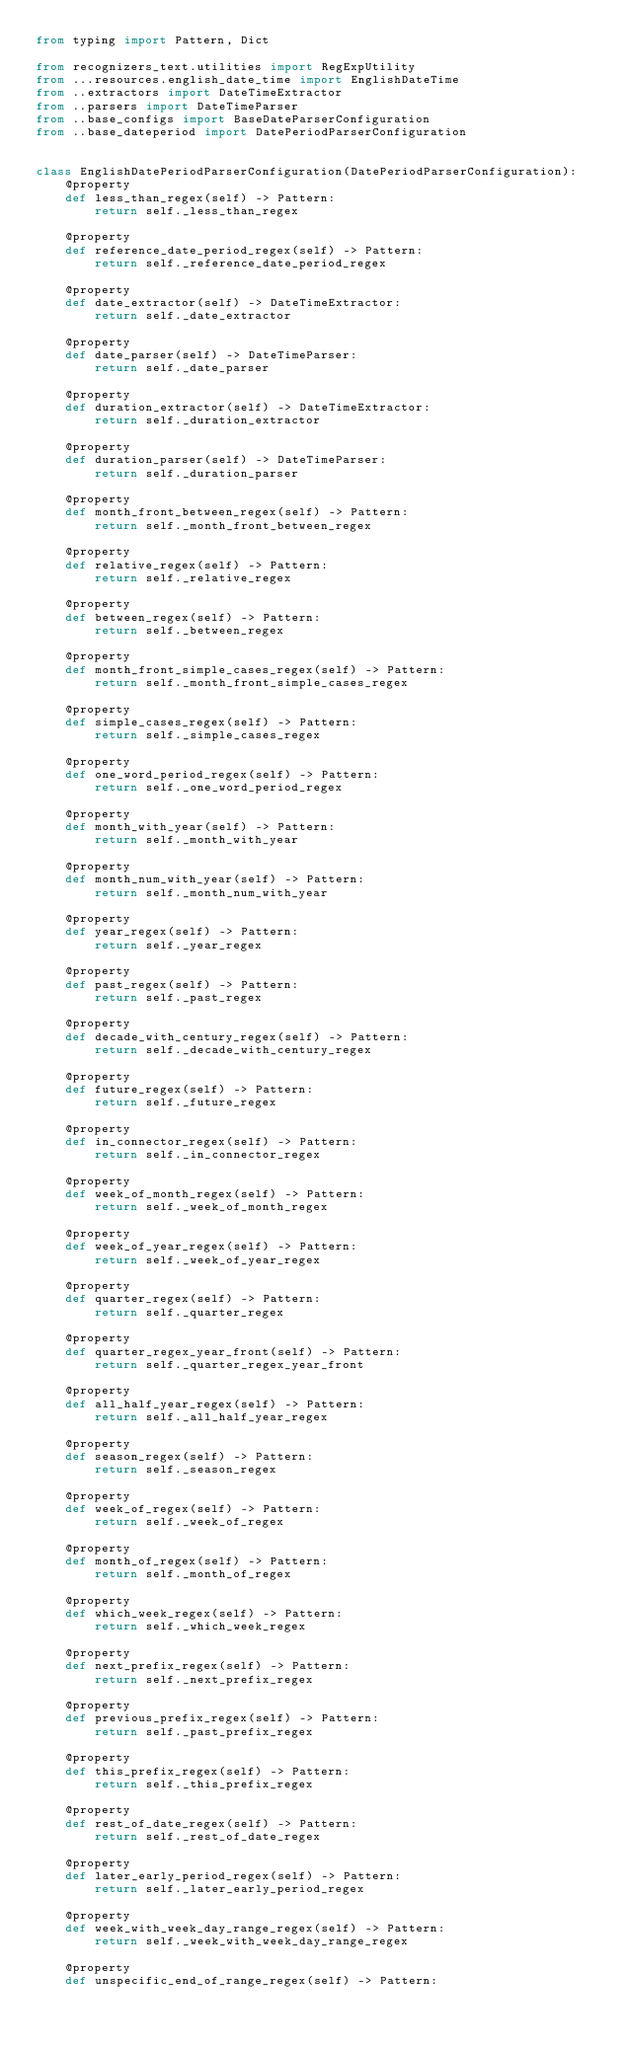<code> <loc_0><loc_0><loc_500><loc_500><_Python_>from typing import Pattern, Dict

from recognizers_text.utilities import RegExpUtility
from ...resources.english_date_time import EnglishDateTime
from ..extractors import DateTimeExtractor
from ..parsers import DateTimeParser
from ..base_configs import BaseDateParserConfiguration
from ..base_dateperiod import DatePeriodParserConfiguration


class EnglishDatePeriodParserConfiguration(DatePeriodParserConfiguration):
    @property
    def less_than_regex(self) -> Pattern:
        return self._less_than_regex

    @property
    def reference_date_period_regex(self) -> Pattern:
        return self._reference_date_period_regex

    @property
    def date_extractor(self) -> DateTimeExtractor:
        return self._date_extractor

    @property
    def date_parser(self) -> DateTimeParser:
        return self._date_parser

    @property
    def duration_extractor(self) -> DateTimeExtractor:
        return self._duration_extractor

    @property
    def duration_parser(self) -> DateTimeParser:
        return self._duration_parser

    @property
    def month_front_between_regex(self) -> Pattern:
        return self._month_front_between_regex

    @property
    def relative_regex(self) -> Pattern:
        return self._relative_regex

    @property
    def between_regex(self) -> Pattern:
        return self._between_regex

    @property
    def month_front_simple_cases_regex(self) -> Pattern:
        return self._month_front_simple_cases_regex

    @property
    def simple_cases_regex(self) -> Pattern:
        return self._simple_cases_regex

    @property
    def one_word_period_regex(self) -> Pattern:
        return self._one_word_period_regex

    @property
    def month_with_year(self) -> Pattern:
        return self._month_with_year

    @property
    def month_num_with_year(self) -> Pattern:
        return self._month_num_with_year

    @property
    def year_regex(self) -> Pattern:
        return self._year_regex

    @property
    def past_regex(self) -> Pattern:
        return self._past_regex

    @property
    def decade_with_century_regex(self) -> Pattern:
        return self._decade_with_century_regex

    @property
    def future_regex(self) -> Pattern:
        return self._future_regex

    @property
    def in_connector_regex(self) -> Pattern:
        return self._in_connector_regex

    @property
    def week_of_month_regex(self) -> Pattern:
        return self._week_of_month_regex

    @property
    def week_of_year_regex(self) -> Pattern:
        return self._week_of_year_regex

    @property
    def quarter_regex(self) -> Pattern:
        return self._quarter_regex

    @property
    def quarter_regex_year_front(self) -> Pattern:
        return self._quarter_regex_year_front

    @property
    def all_half_year_regex(self) -> Pattern:
        return self._all_half_year_regex

    @property
    def season_regex(self) -> Pattern:
        return self._season_regex

    @property
    def week_of_regex(self) -> Pattern:
        return self._week_of_regex

    @property
    def month_of_regex(self) -> Pattern:
        return self._month_of_regex

    @property
    def which_week_regex(self) -> Pattern:
        return self._which_week_regex

    @property
    def next_prefix_regex(self) -> Pattern:
        return self._next_prefix_regex

    @property
    def previous_prefix_regex(self) -> Pattern:
        return self._past_prefix_regex

    @property
    def this_prefix_regex(self) -> Pattern:
        return self._this_prefix_regex

    @property
    def rest_of_date_regex(self) -> Pattern:
        return self._rest_of_date_regex

    @property
    def later_early_period_regex(self) -> Pattern:
        return self._later_early_period_regex

    @property
    def week_with_week_day_range_regex(self) -> Pattern:
        return self._week_with_week_day_range_regex

    @property
    def unspecific_end_of_range_regex(self) -> Pattern:</code> 